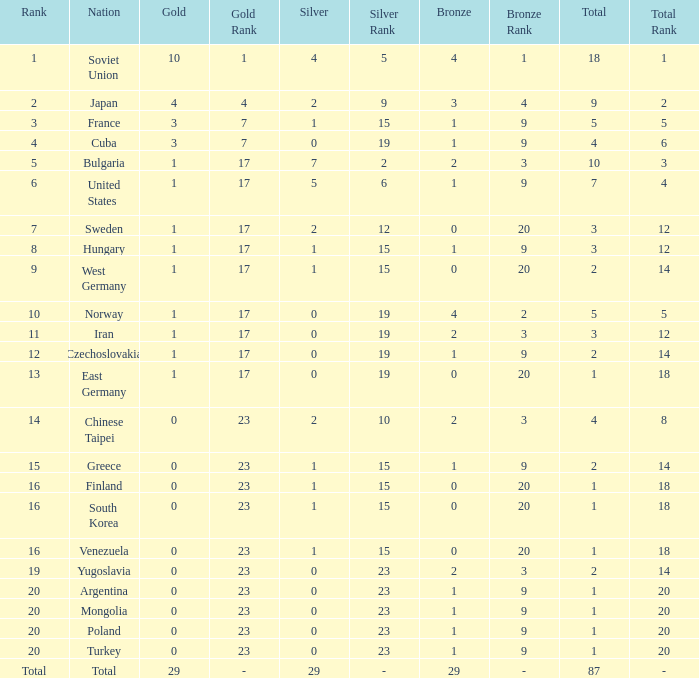Which rank has 1 silver medal and more than 1 gold medal? 3.0. 